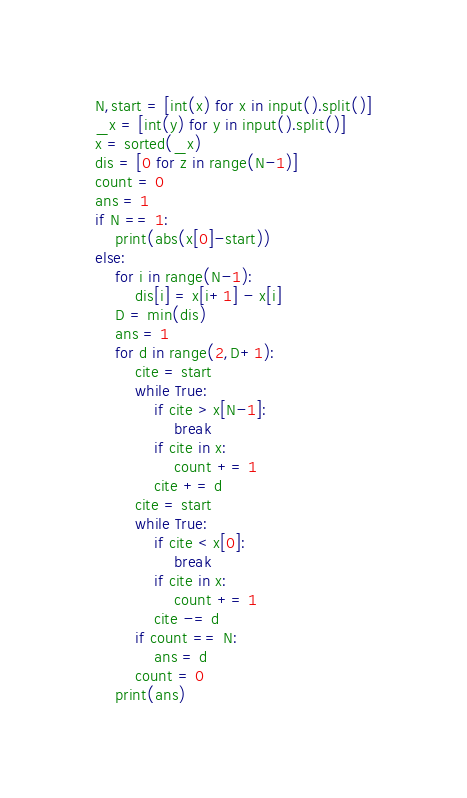Convert code to text. <code><loc_0><loc_0><loc_500><loc_500><_Python_>N,start = [int(x) for x in input().split()]
_x = [int(y) for y in input().split()]
x = sorted(_x)
dis = [0 for z in range(N-1)]
count = 0
ans = 1
if N == 1:
    print(abs(x[0]-start))
else:
    for i in range(N-1):
        dis[i] = x[i+1] - x[i]
    D = min(dis)
    ans = 1
    for d in range(2,D+1):
        cite = start
        while True:
            if cite > x[N-1]:
                break
            if cite in x:
                count += 1
            cite += d
        cite = start
        while True:
            if cite < x[0]:
                break
            if cite in x:
                count += 1
            cite -= d
        if count == N:
            ans = d
        count = 0
    print(ans)
</code> 